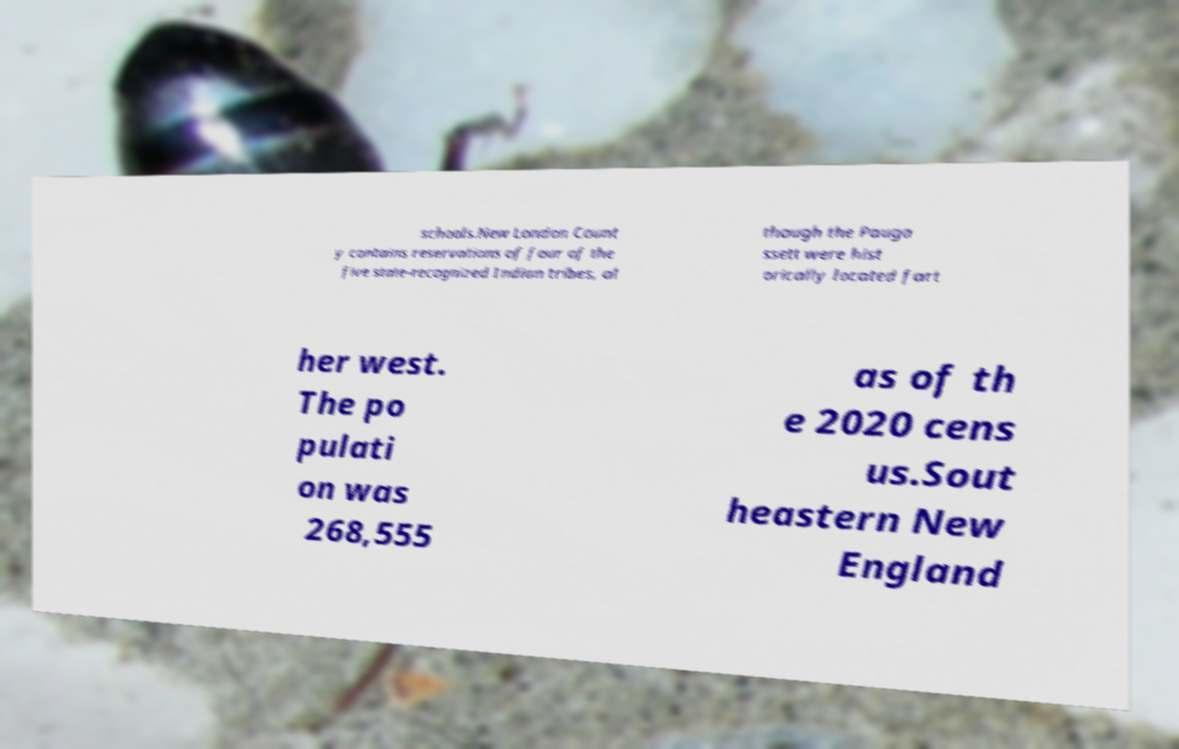I need the written content from this picture converted into text. Can you do that? schools.New London Count y contains reservations of four of the five state-recognized Indian tribes, al though the Pauga ssett were hist orically located fart her west. The po pulati on was 268,555 as of th e 2020 cens us.Sout heastern New England 